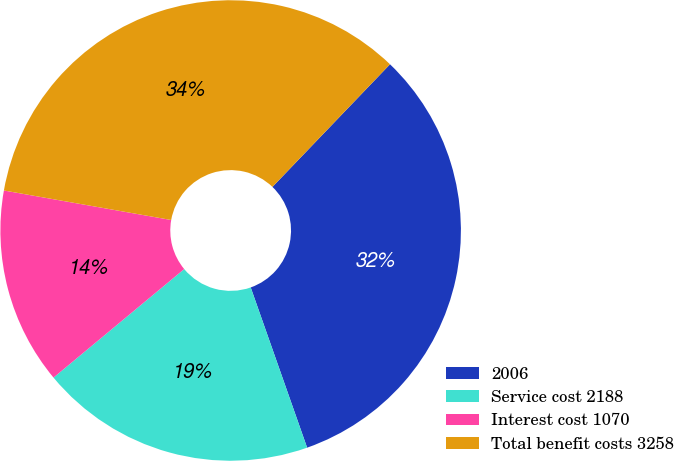Convert chart. <chart><loc_0><loc_0><loc_500><loc_500><pie_chart><fcel>2006<fcel>Service cost 2188<fcel>Interest cost 1070<fcel>Total benefit costs 3258<nl><fcel>32.45%<fcel>19.36%<fcel>13.81%<fcel>34.39%<nl></chart> 